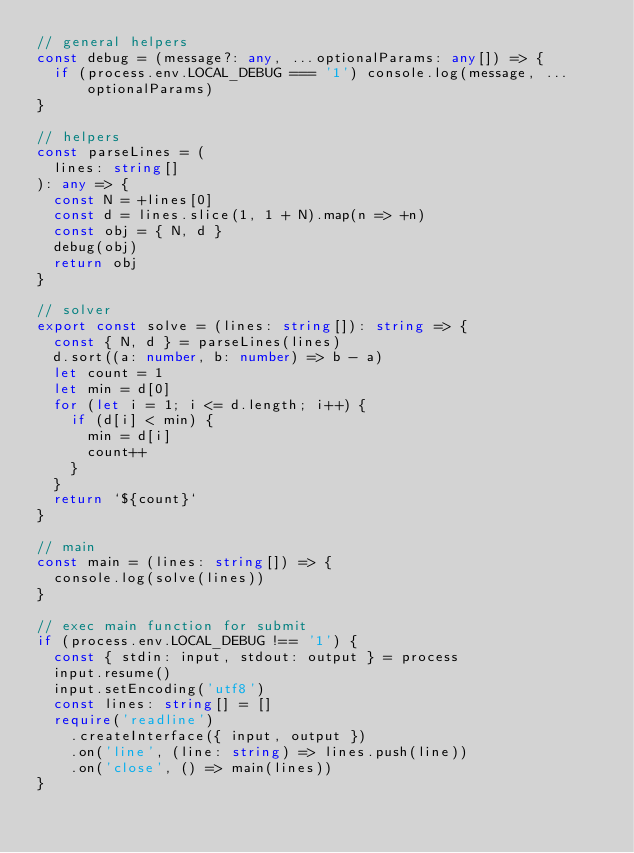Convert code to text. <code><loc_0><loc_0><loc_500><loc_500><_TypeScript_>// general helpers
const debug = (message?: any, ...optionalParams: any[]) => {
  if (process.env.LOCAL_DEBUG === '1') console.log(message, ...optionalParams)
}

// helpers
const parseLines = (
  lines: string[]
): any => {
  const N = +lines[0]
  const d = lines.slice(1, 1 + N).map(n => +n)
  const obj = { N, d }
  debug(obj)
  return obj
}

// solver
export const solve = (lines: string[]): string => {
  const { N, d } = parseLines(lines)
  d.sort((a: number, b: number) => b - a)
  let count = 1
  let min = d[0]
  for (let i = 1; i <= d.length; i++) {
    if (d[i] < min) {
      min = d[i]
      count++
    }
  }
  return `${count}`
}

// main
const main = (lines: string[]) => {
  console.log(solve(lines))
}

// exec main function for submit
if (process.env.LOCAL_DEBUG !== '1') {
  const { stdin: input, stdout: output } = process
  input.resume()
  input.setEncoding('utf8')
  const lines: string[] = []
  require('readline')
    .createInterface({ input, output })
    .on('line', (line: string) => lines.push(line))
    .on('close', () => main(lines))
}
</code> 